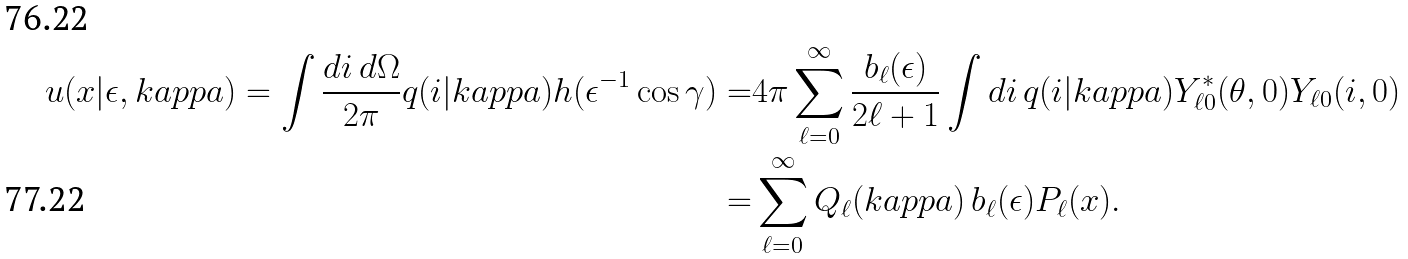Convert formula to latex. <formula><loc_0><loc_0><loc_500><loc_500>u ( x | \epsilon , k a p p a ) = \int \frac { d i \, d \Omega } { 2 \pi } q ( i | k a p p a ) h ( \epsilon ^ { - 1 } \cos \gamma ) = & 4 \pi \sum _ { \ell = 0 } ^ { \infty } \frac { b _ { \ell } ( \epsilon ) } { 2 \ell + 1 } \int d i \, q ( i | k a p p a ) Y _ { \ell 0 } ^ { \ast } ( \theta , 0 ) Y _ { \ell 0 } ( i , 0 ) \\ = & \sum _ { \ell = 0 } ^ { \infty } Q _ { \ell } ( k a p p a ) \, b _ { \ell } ( \epsilon ) P _ { \ell } ( x ) .</formula> 